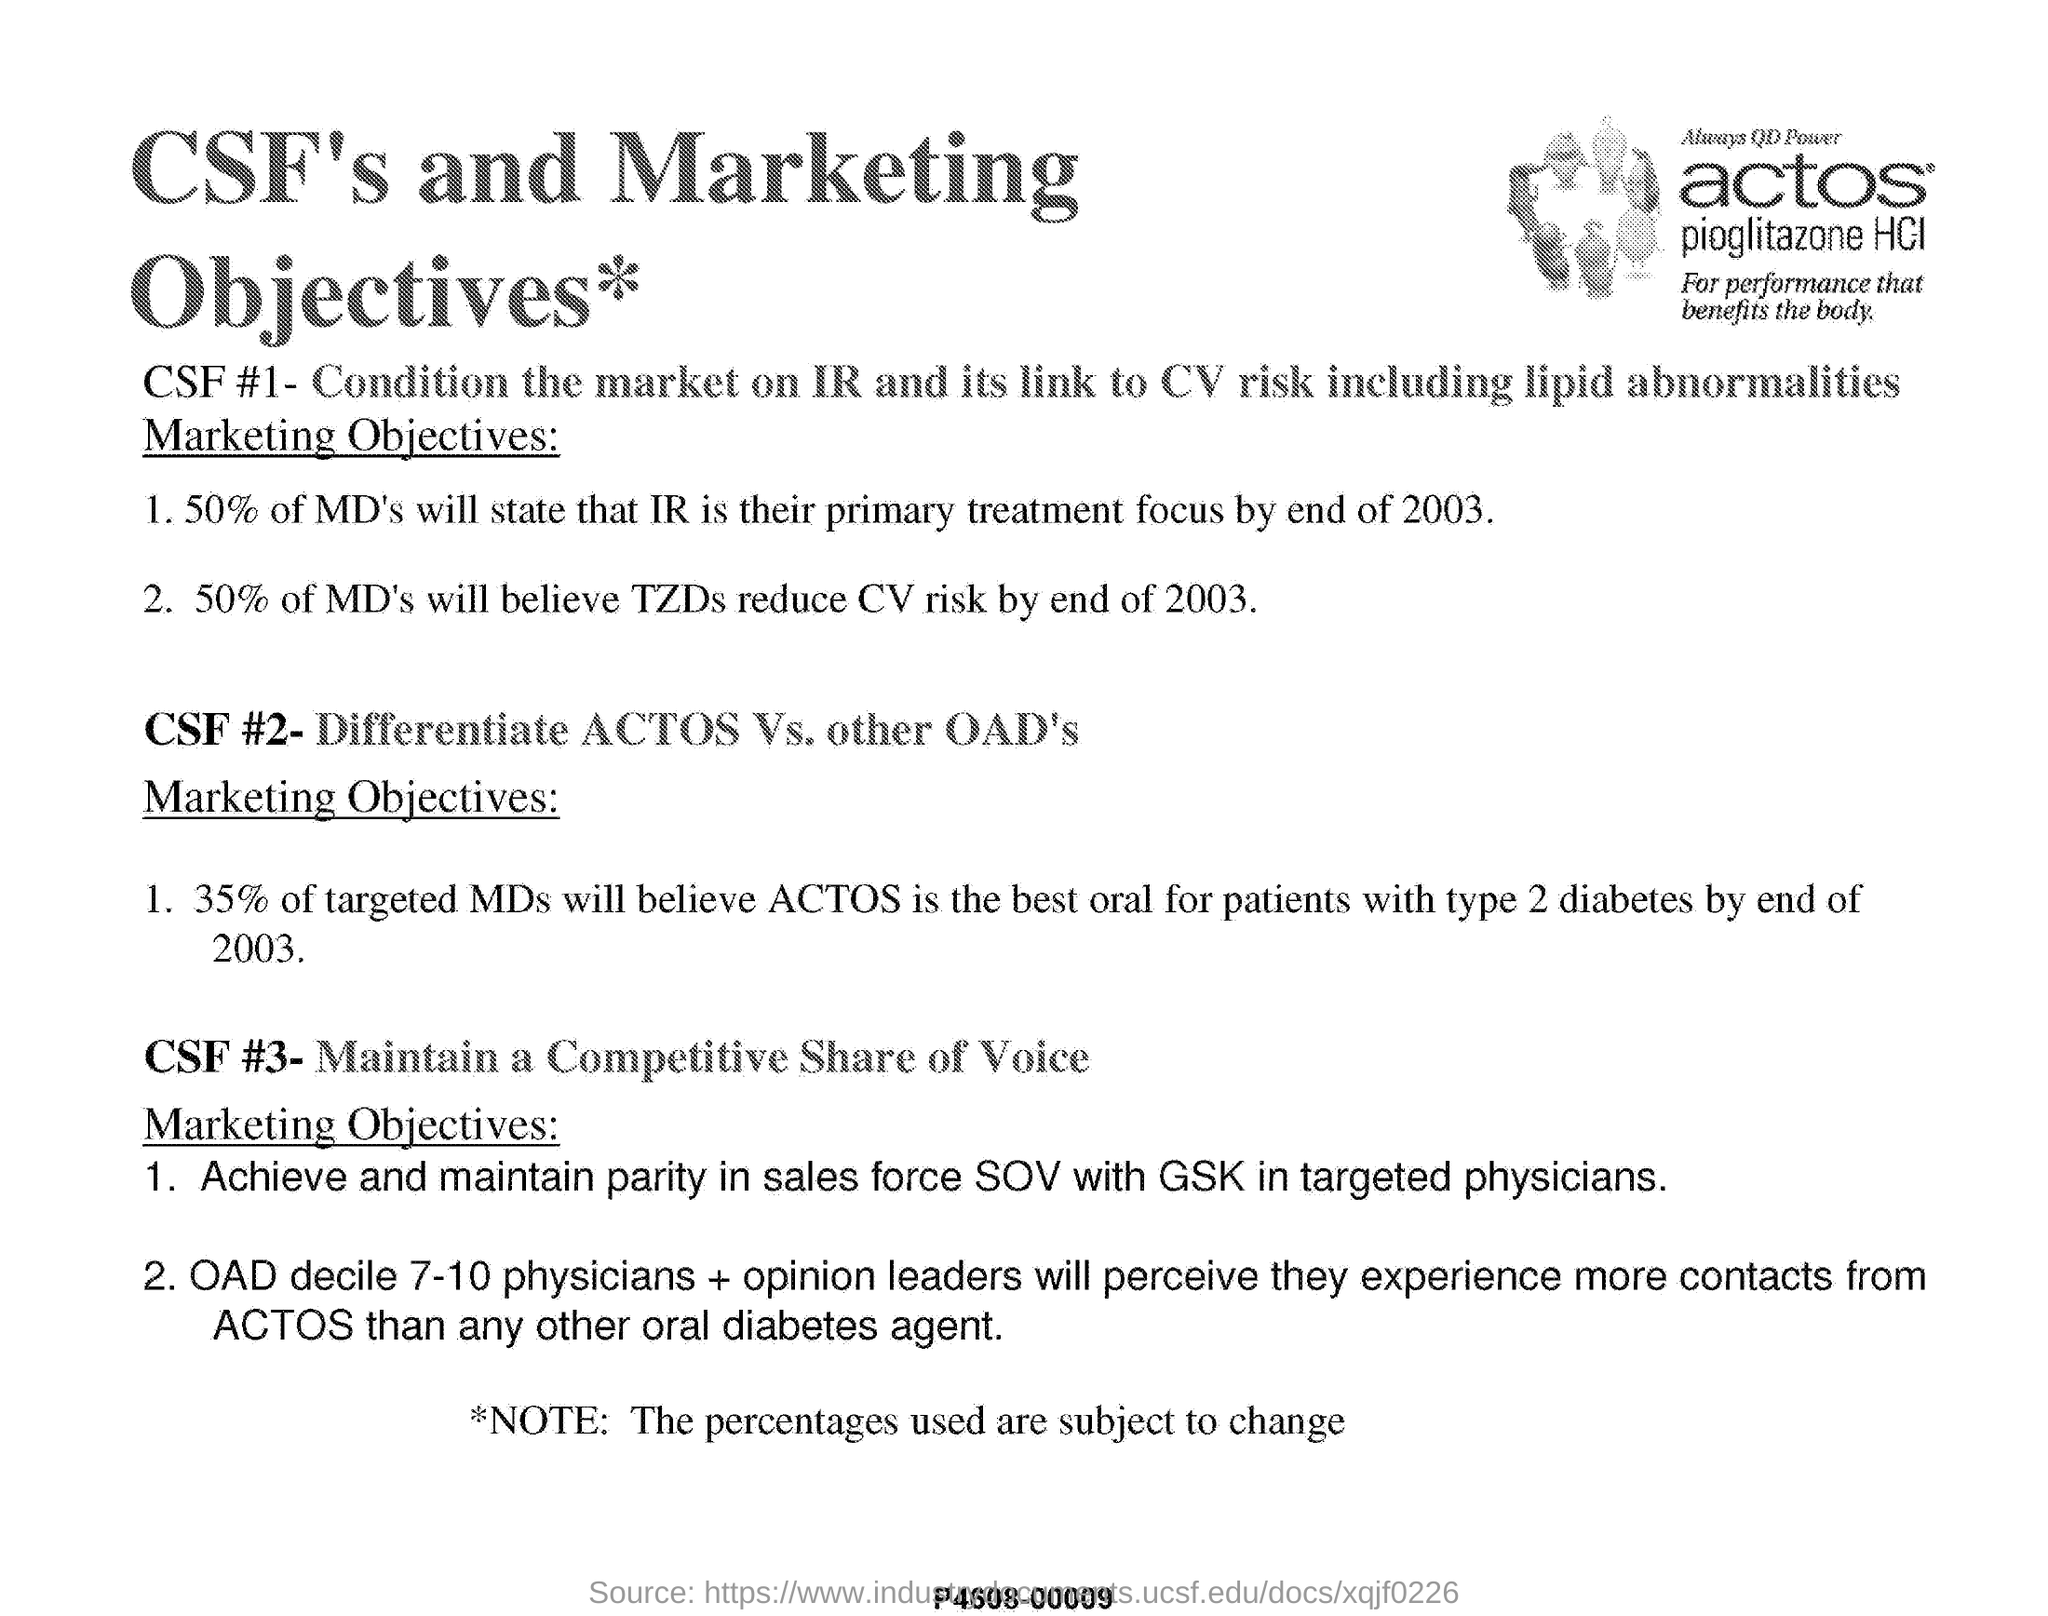What is the title mentioned in this document?
Keep it short and to the point. CSF's and Marketing Objectives. 